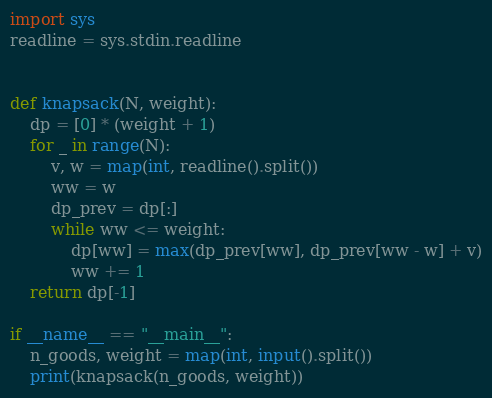<code> <loc_0><loc_0><loc_500><loc_500><_Python_>import sys
readline = sys.stdin.readline


def knapsack(N, weight):
    dp = [0] * (weight + 1)
    for _ in range(N):
        v, w = map(int, readline().split())
        ww = w
        dp_prev = dp[:]
        while ww <= weight:
            dp[ww] = max(dp_prev[ww], dp_prev[ww - w] + v)
            ww += 1
    return dp[-1]

if __name__ == "__main__":
    n_goods, weight = map(int, input().split())
    print(knapsack(n_goods, weight))

</code> 